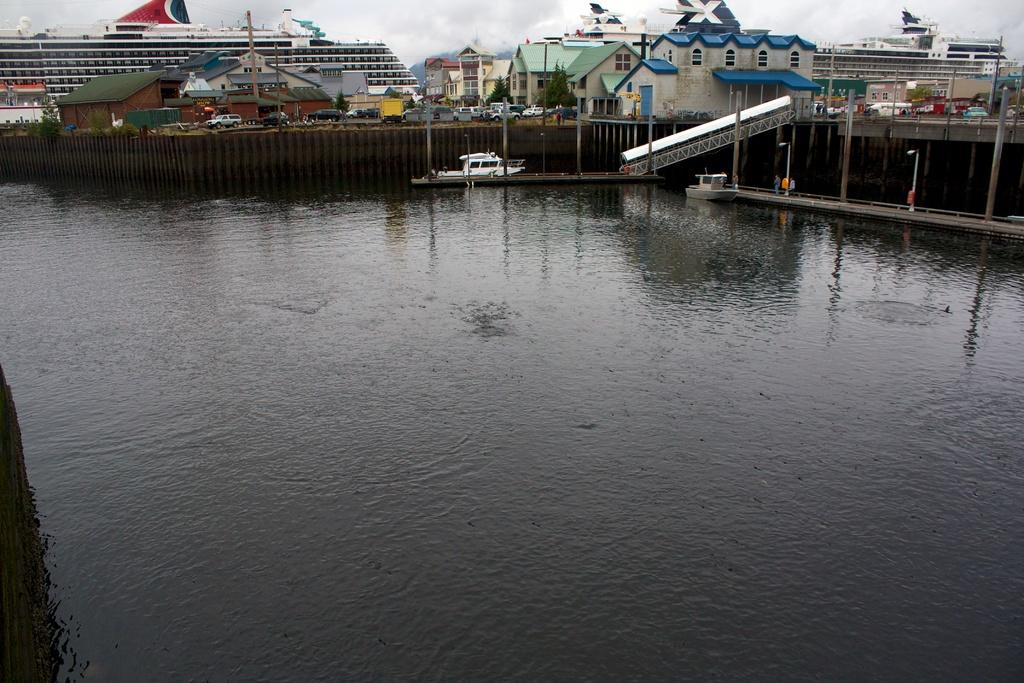What is on the water in the image? There are boats on the water in the image. What type of structure is present over the water? There is a bridge with poles in the image. What can be seen in the distance in the image? There are vehicles and buildings visible in the background of the image. What is visible in the sky in the image? The sky is visible in the background of the image. What type of creature is swimming in the water next to the boats? There is no creature swimming in the water next to the boats in the image. Can you tell me how many people are standing on the bridge? There is no person standing on the bridge in the image. 